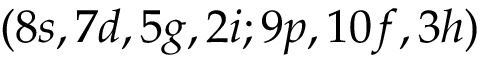<formula> <loc_0><loc_0><loc_500><loc_500>( 8 s , 7 d , 5 g , 2 i ; 9 p , 1 0 f , 3 h )</formula> 